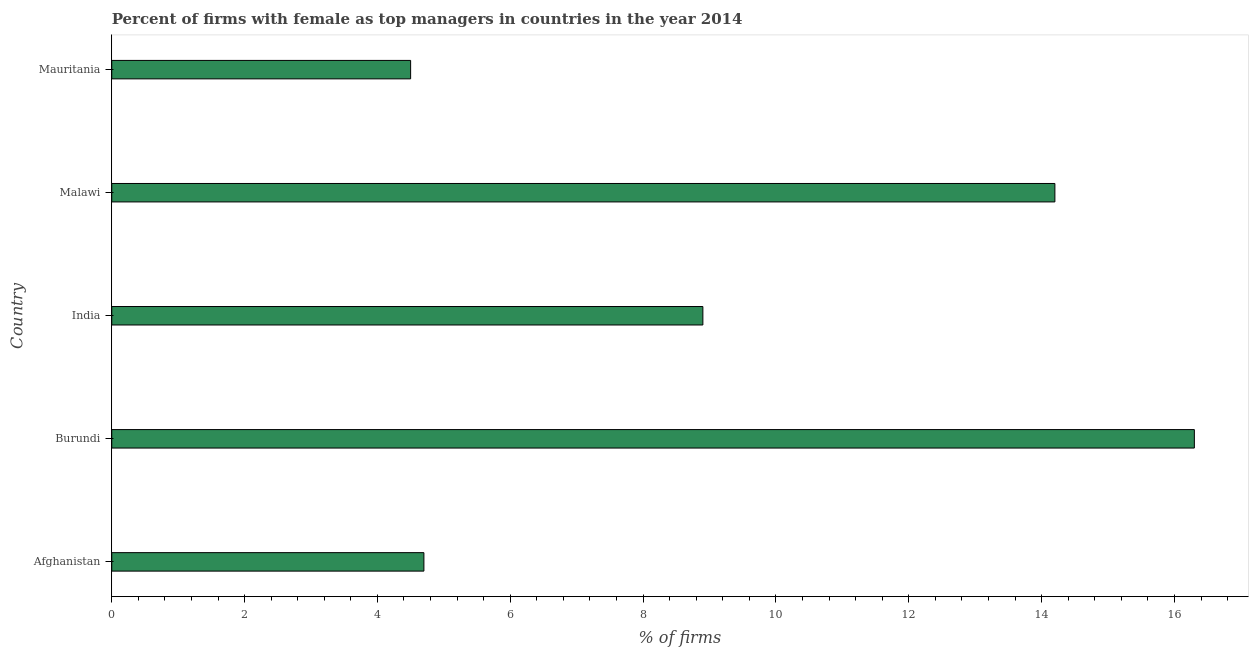Does the graph contain grids?
Keep it short and to the point. No. What is the title of the graph?
Offer a terse response. Percent of firms with female as top managers in countries in the year 2014. What is the label or title of the X-axis?
Offer a very short reply. % of firms. What is the percentage of firms with female as top manager in Malawi?
Your answer should be very brief. 14.2. In which country was the percentage of firms with female as top manager maximum?
Provide a short and direct response. Burundi. In which country was the percentage of firms with female as top manager minimum?
Provide a short and direct response. Mauritania. What is the sum of the percentage of firms with female as top manager?
Ensure brevity in your answer.  48.6. What is the average percentage of firms with female as top manager per country?
Your answer should be very brief. 9.72. In how many countries, is the percentage of firms with female as top manager greater than 12 %?
Make the answer very short. 2. What is the ratio of the percentage of firms with female as top manager in Afghanistan to that in Malawi?
Provide a succinct answer. 0.33. Is the difference between the percentage of firms with female as top manager in Burundi and Malawi greater than the difference between any two countries?
Ensure brevity in your answer.  No. What is the difference between the highest and the second highest percentage of firms with female as top manager?
Provide a succinct answer. 2.1. Is the sum of the percentage of firms with female as top manager in Afghanistan and India greater than the maximum percentage of firms with female as top manager across all countries?
Your answer should be compact. No. In how many countries, is the percentage of firms with female as top manager greater than the average percentage of firms with female as top manager taken over all countries?
Provide a succinct answer. 2. How many bars are there?
Your response must be concise. 5. Are all the bars in the graph horizontal?
Provide a short and direct response. Yes. What is the difference between two consecutive major ticks on the X-axis?
Offer a very short reply. 2. What is the % of firms of India?
Make the answer very short. 8.9. What is the % of firms of Mauritania?
Give a very brief answer. 4.5. What is the difference between the % of firms in Afghanistan and Burundi?
Offer a very short reply. -11.6. What is the difference between the % of firms in Afghanistan and India?
Ensure brevity in your answer.  -4.2. What is the difference between the % of firms in Afghanistan and Mauritania?
Give a very brief answer. 0.2. What is the difference between the % of firms in Burundi and India?
Make the answer very short. 7.4. What is the difference between the % of firms in Burundi and Mauritania?
Your answer should be very brief. 11.8. What is the difference between the % of firms in India and Mauritania?
Offer a very short reply. 4.4. What is the difference between the % of firms in Malawi and Mauritania?
Keep it short and to the point. 9.7. What is the ratio of the % of firms in Afghanistan to that in Burundi?
Give a very brief answer. 0.29. What is the ratio of the % of firms in Afghanistan to that in India?
Give a very brief answer. 0.53. What is the ratio of the % of firms in Afghanistan to that in Malawi?
Your answer should be compact. 0.33. What is the ratio of the % of firms in Afghanistan to that in Mauritania?
Your answer should be very brief. 1.04. What is the ratio of the % of firms in Burundi to that in India?
Your answer should be very brief. 1.83. What is the ratio of the % of firms in Burundi to that in Malawi?
Keep it short and to the point. 1.15. What is the ratio of the % of firms in Burundi to that in Mauritania?
Make the answer very short. 3.62. What is the ratio of the % of firms in India to that in Malawi?
Provide a short and direct response. 0.63. What is the ratio of the % of firms in India to that in Mauritania?
Provide a short and direct response. 1.98. What is the ratio of the % of firms in Malawi to that in Mauritania?
Your answer should be compact. 3.16. 